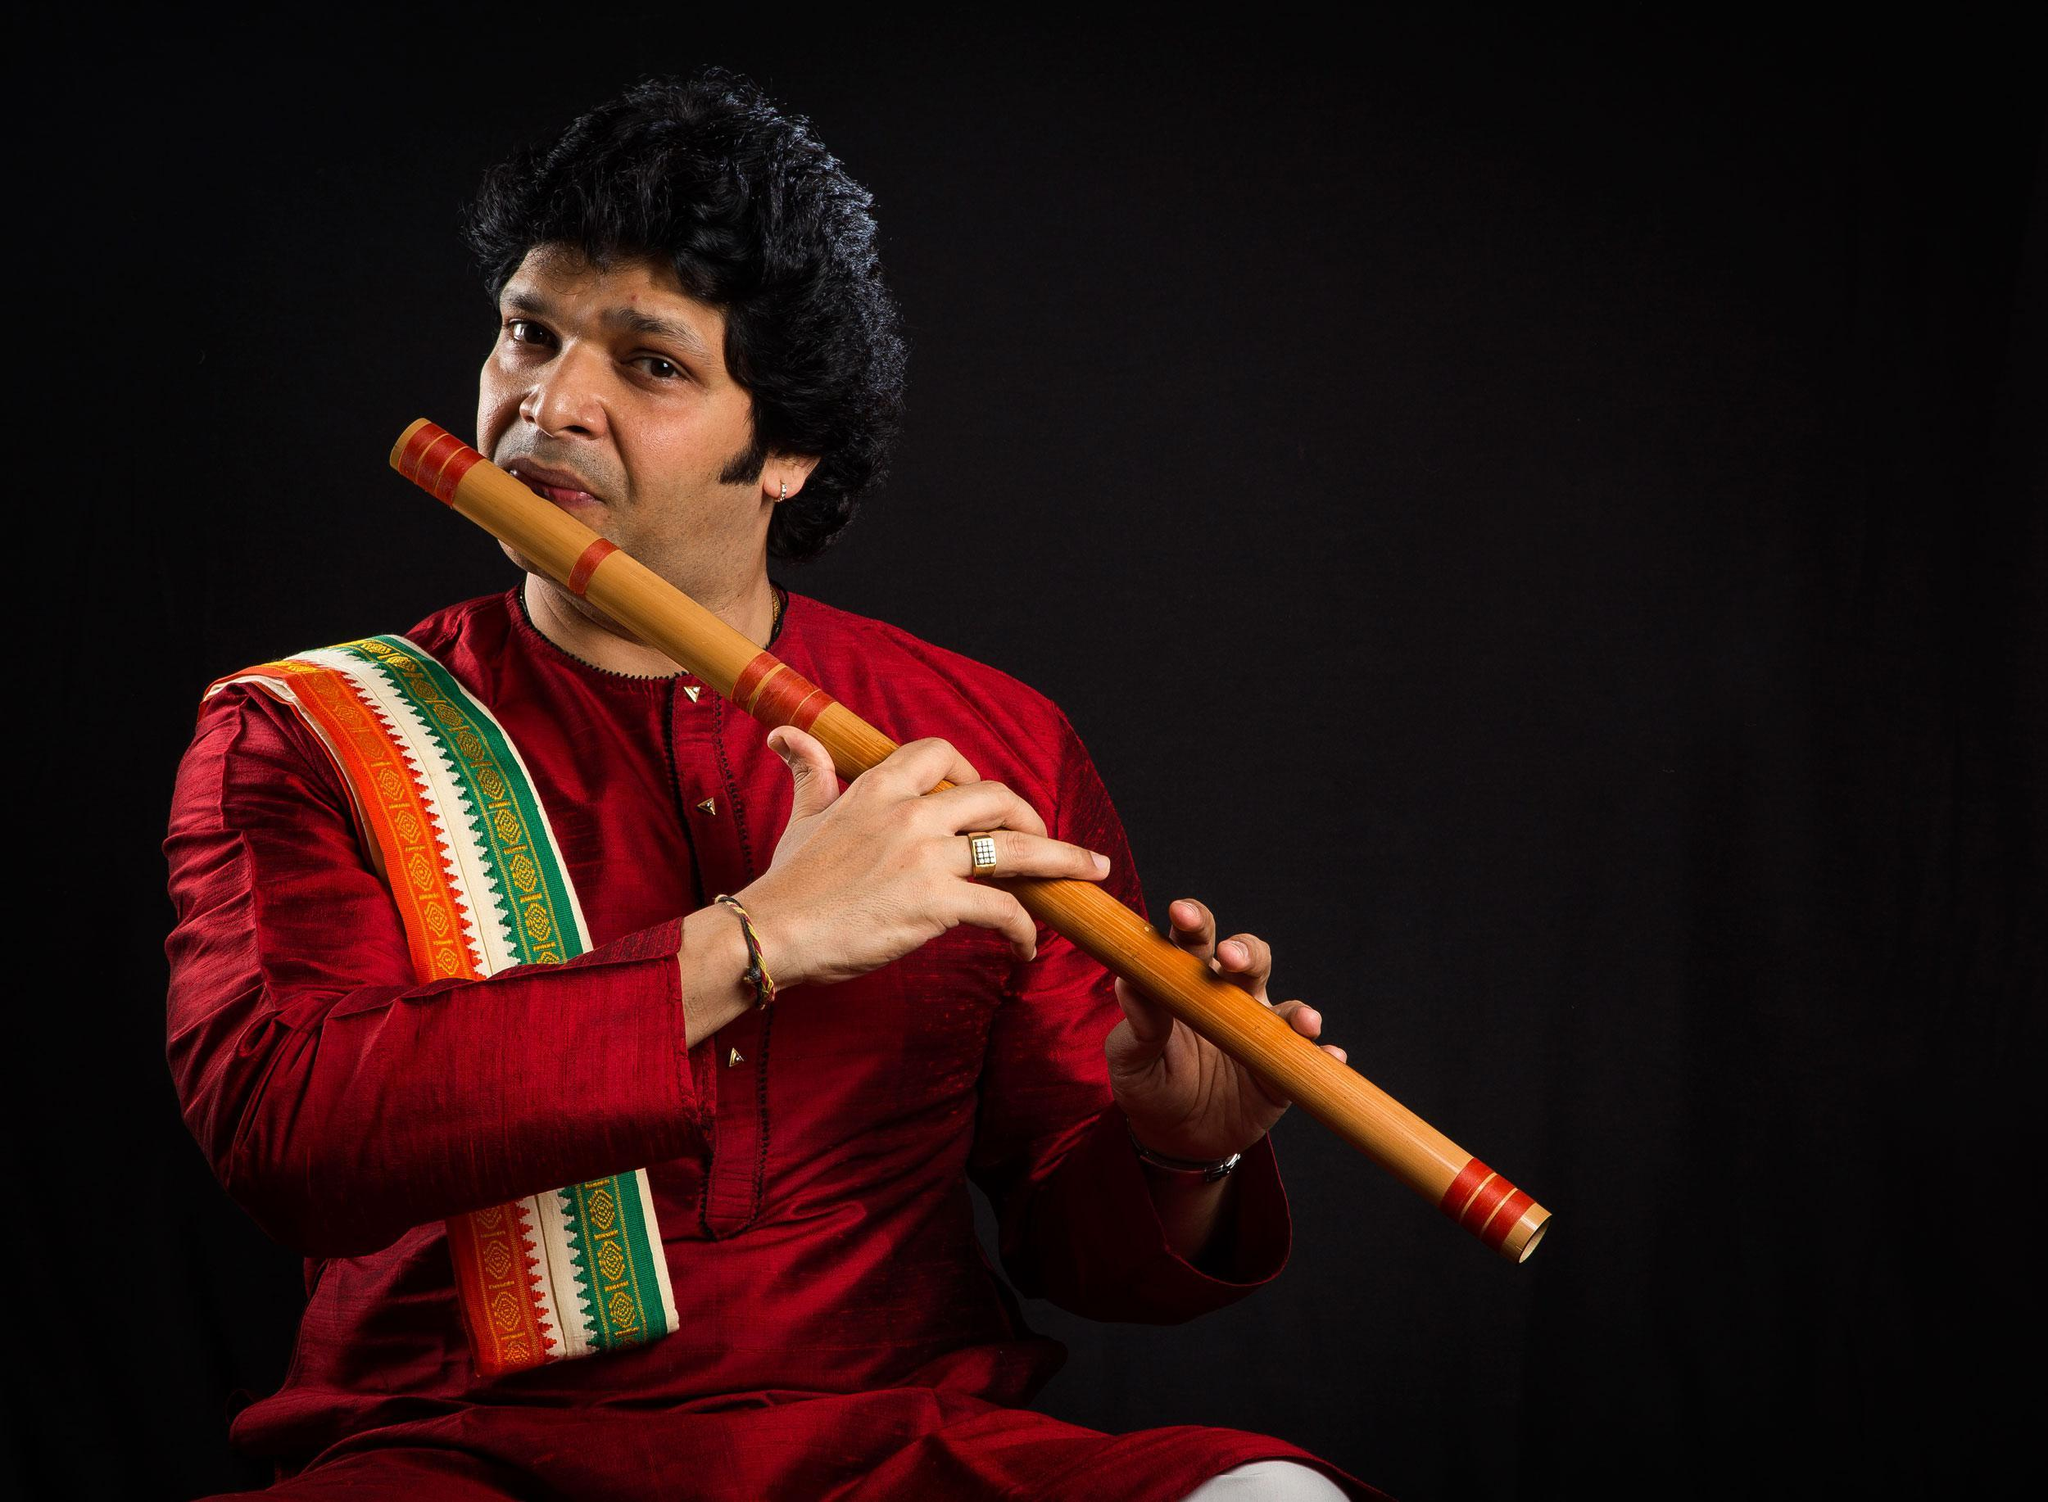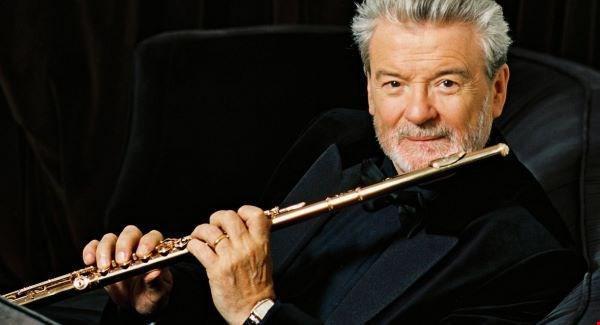The first image is the image on the left, the second image is the image on the right. Analyze the images presented: Is the assertion "a man in a button down shirt with a striped banner on his shoulder is playing a wooden flute" valid? Answer yes or no. Yes. The first image is the image on the left, the second image is the image on the right. Examine the images to the left and right. Is the description "The left image contains a man in a red long sleeved shirt playing a musical instrument." accurate? Answer yes or no. Yes. 